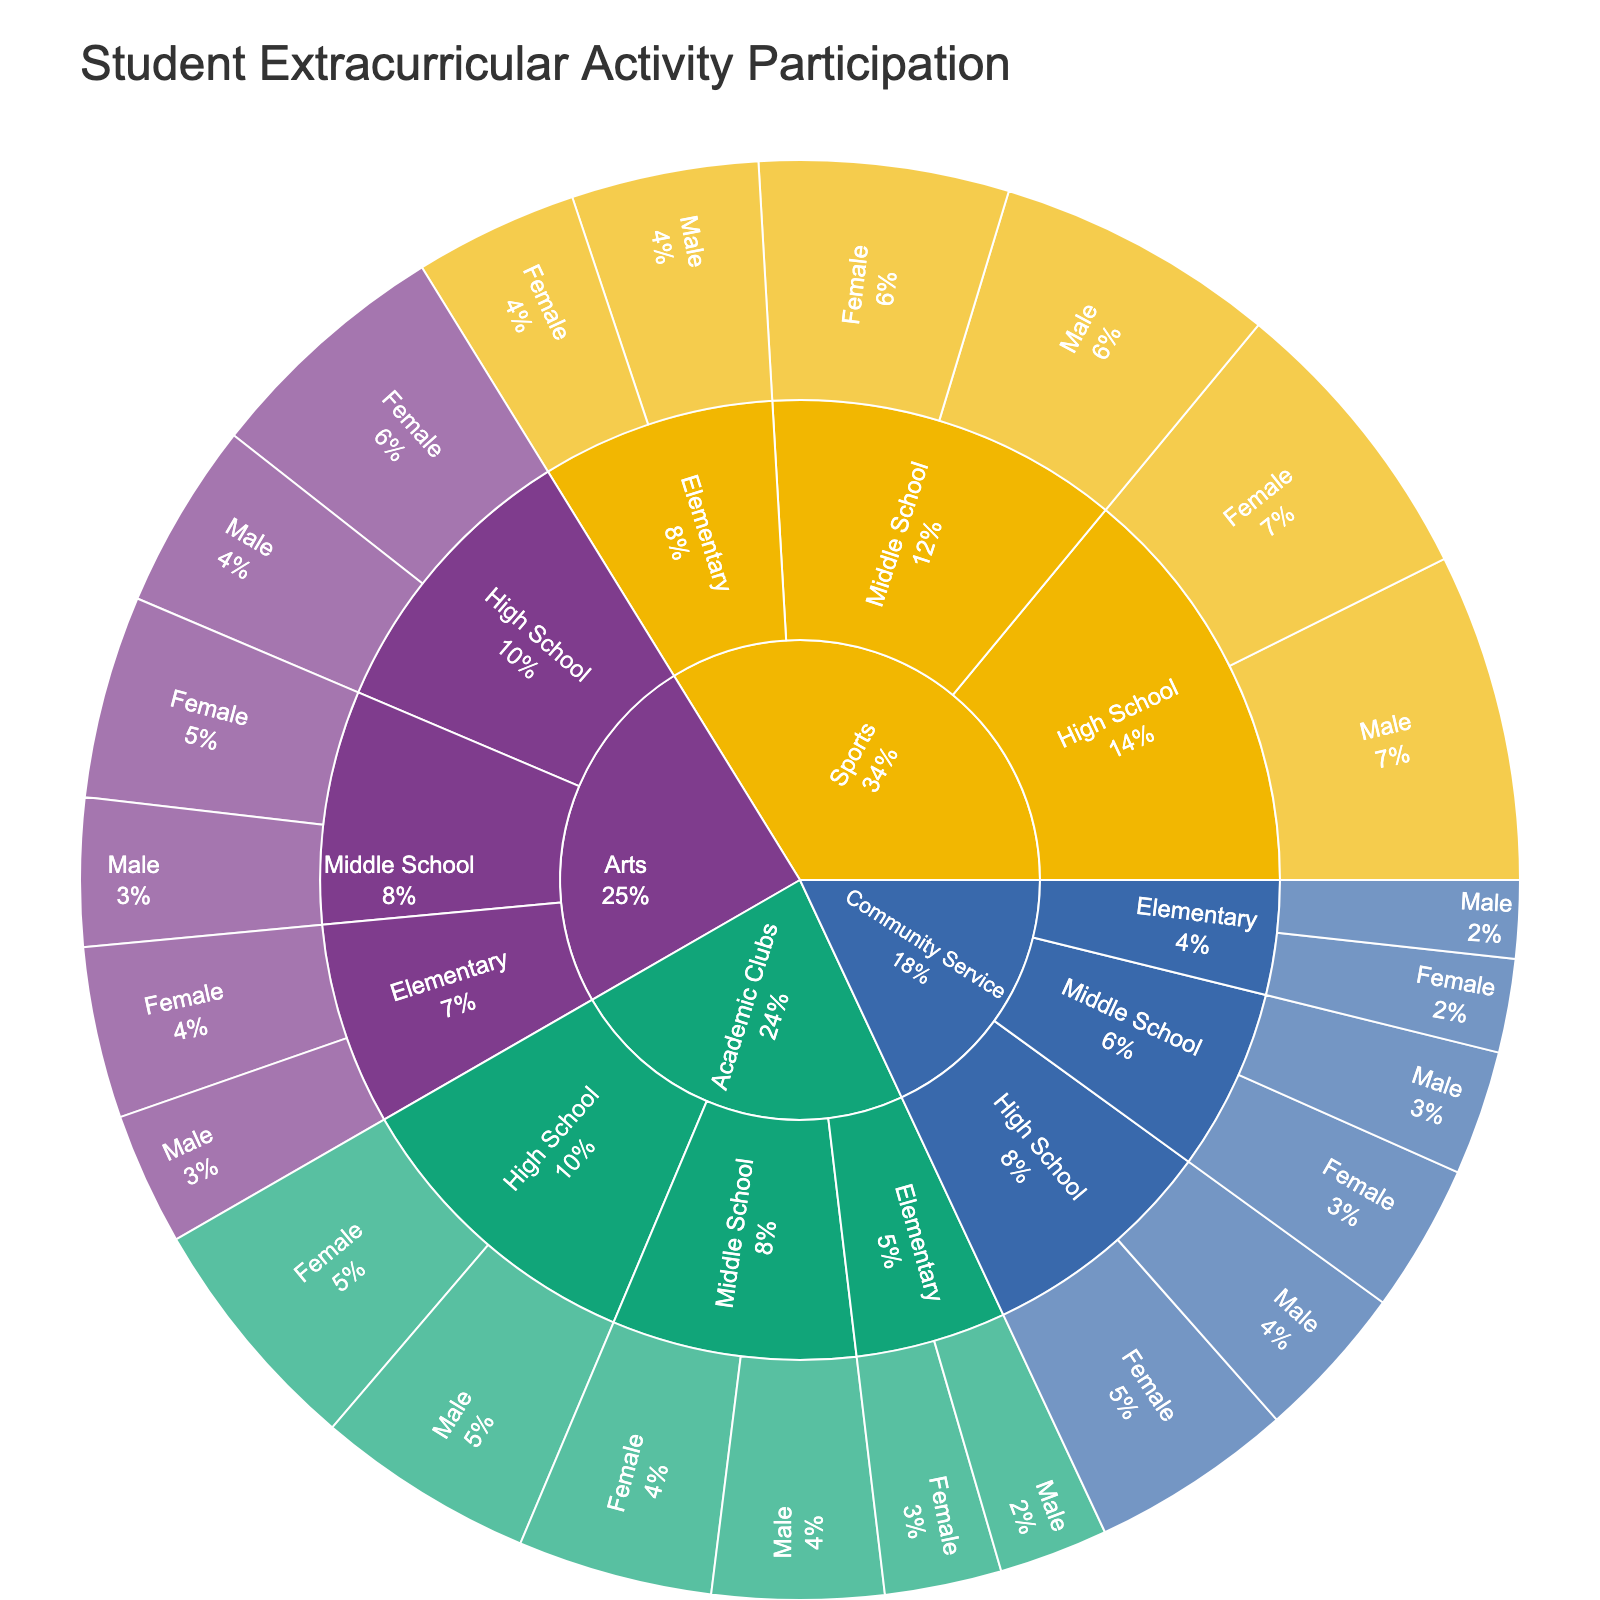What is the title of the Sunburst Plot? The title of the plot is usually positioned at the top of the figure. By looking at the plot, we can identify that it reads "Student Extracurricular Activity Participation".
Answer: Student Extracurricular Activity Participation How many main categories of extracurricular activities are shown? The Sunburst Plot is divided into main segments, which represent the major categories of extracurricular activities. By observing the figure, we count the distinct segments at the outermost level.
Answer: Four Which grade level has the highest participation in sports by males? To answer this, we focus on the segment labeled "Sports", and then look at the sub-segment for "Male" under each grade level. We compare the participation numbers to determine the highest one.
Answer: High School What is the total participation for females in Arts activities across all grade levels? We need to identify the female participation in Arts for each grade level (Elementary, Middle School, High School) and sum these values: 110 (Elementary) + 130 (Middle School) + 160 (High School).
Answer: 400 Which gender has higher participation in Academic Clubs at the Middle School level? Under the "Academic Clubs" category and "Middle School" sub-segment, compare the participation numbers for "Male" and "Female".
Answer: Female What percentage of the total extracurricular activities participation does Elementary School males in Community Service represent? Locate the participation number for Elementary School males in Community Service (50). Then, sum all participation numbers in the plot for the total (2720). Finally, calculate the percentage: (50 / 2720) * 100.
Answer: 1.84% Which category has the least participation among Elementary School females? Focus on the Elementary School segment, and then look at each category for females to find the one with the smallest value.
Answer: Community Service How does the participation in Arts compare between Middle School males and females? Within the "Arts" category under "Middle School", compare the participation numbers for males (95) and females (130) to identify the higher participation number.
Answer: Females have higher participation Add the total number of participants in High School sports and High School community service for females. Locate the participation numbers for females in High School sports (190) and High School community service (130) and sum them up: 190 + 130.
Answer: 320 What is the participation difference between males and females in High School Academic Clubs? Find the participation numbers in High School Academic Clubs (males: 140, females: 155) and calculate the difference: 155 - 140.
Answer: 15 